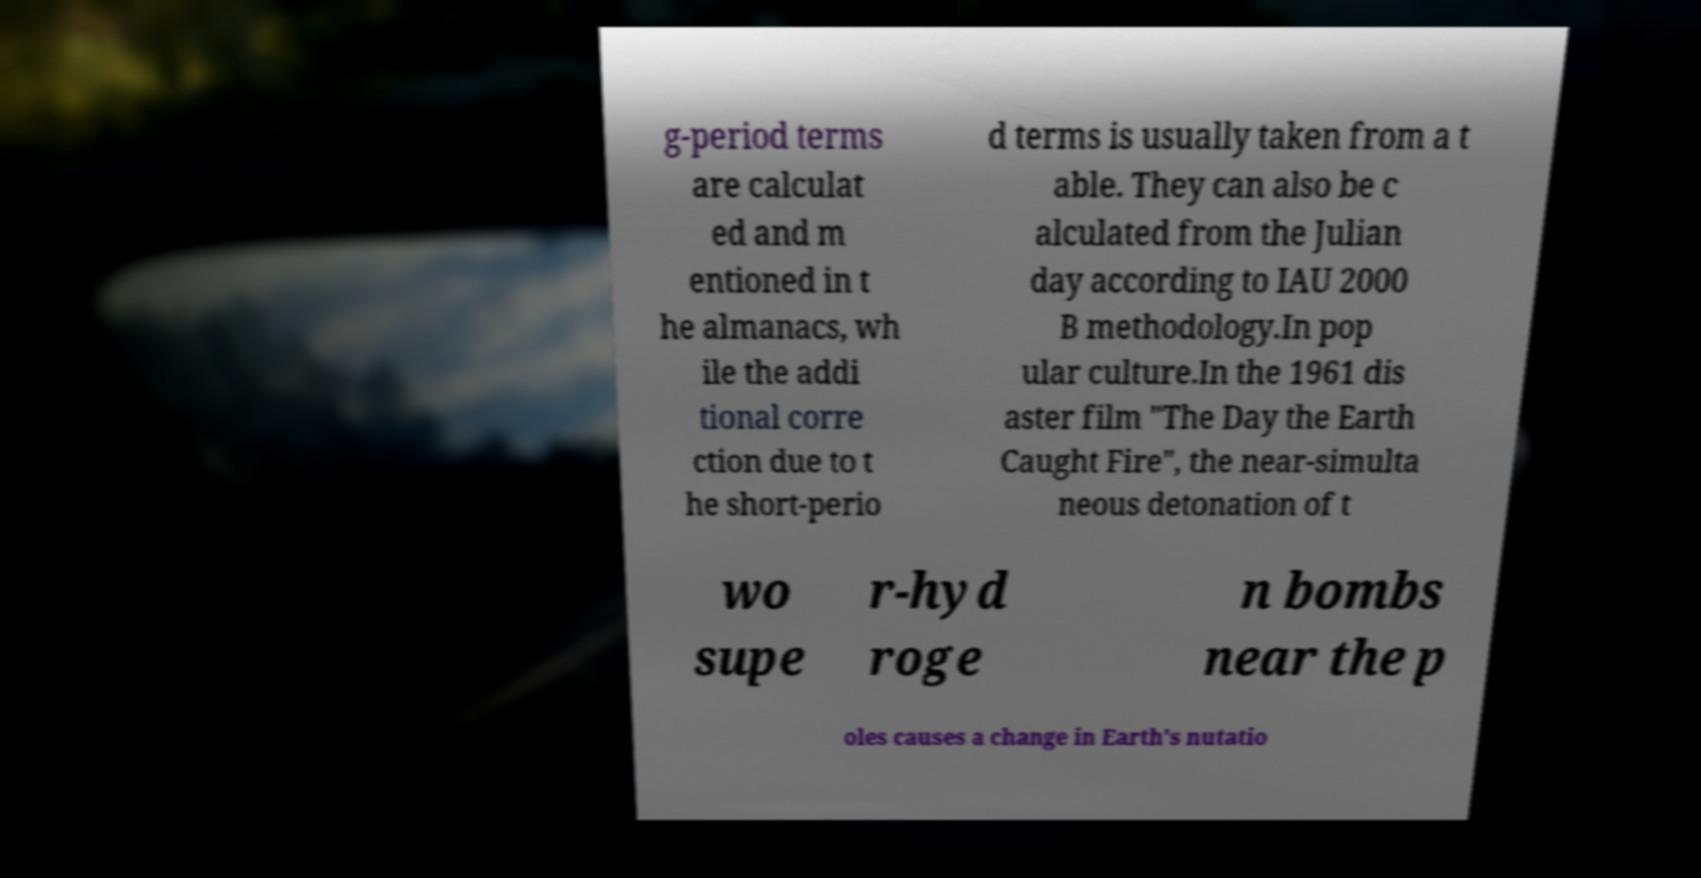I need the written content from this picture converted into text. Can you do that? g-period terms are calculat ed and m entioned in t he almanacs, wh ile the addi tional corre ction due to t he short-perio d terms is usually taken from a t able. They can also be c alculated from the Julian day according to IAU 2000 B methodology.In pop ular culture.In the 1961 dis aster film "The Day the Earth Caught Fire", the near-simulta neous detonation of t wo supe r-hyd roge n bombs near the p oles causes a change in Earth's nutatio 